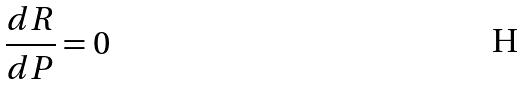<formula> <loc_0><loc_0><loc_500><loc_500>\frac { d R } { d P } = 0</formula> 